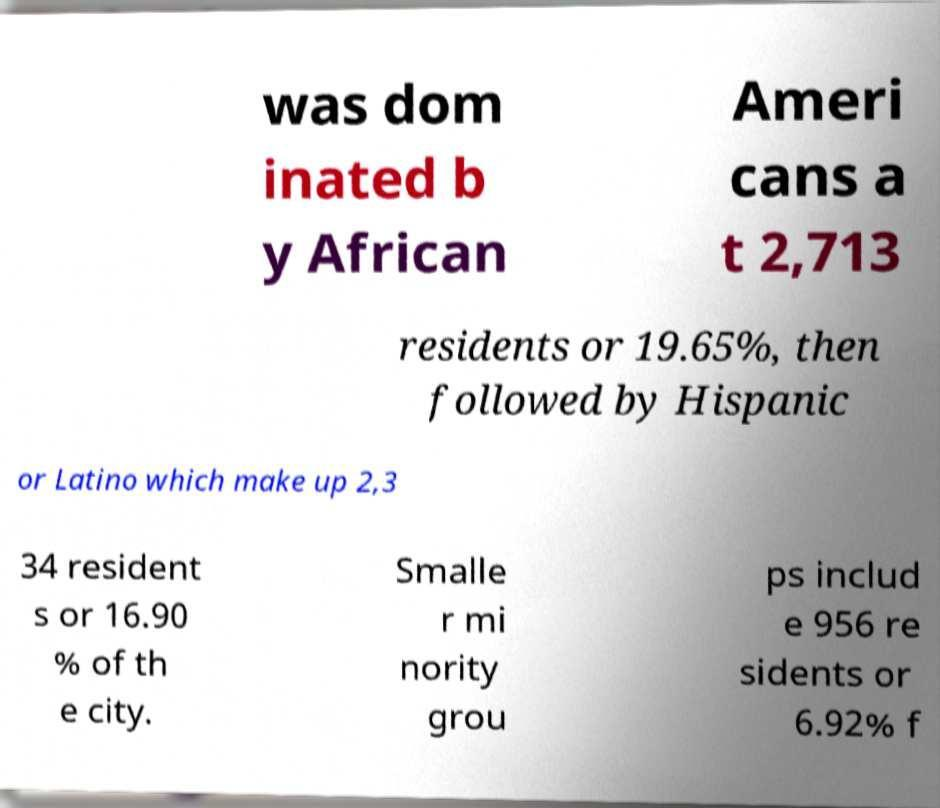Can you read and provide the text displayed in the image?This photo seems to have some interesting text. Can you extract and type it out for me? was dom inated b y African Ameri cans a t 2,713 residents or 19.65%, then followed by Hispanic or Latino which make up 2,3 34 resident s or 16.90 % of th e city. Smalle r mi nority grou ps includ e 956 re sidents or 6.92% f 